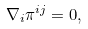Convert formula to latex. <formula><loc_0><loc_0><loc_500><loc_500>\nabla _ { i } \pi ^ { i j } = 0 ,</formula> 